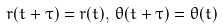<formula> <loc_0><loc_0><loc_500><loc_500>r ( t + \tau ) = r ( t ) , \, \theta ( t + \tau ) = \theta ( t )</formula> 